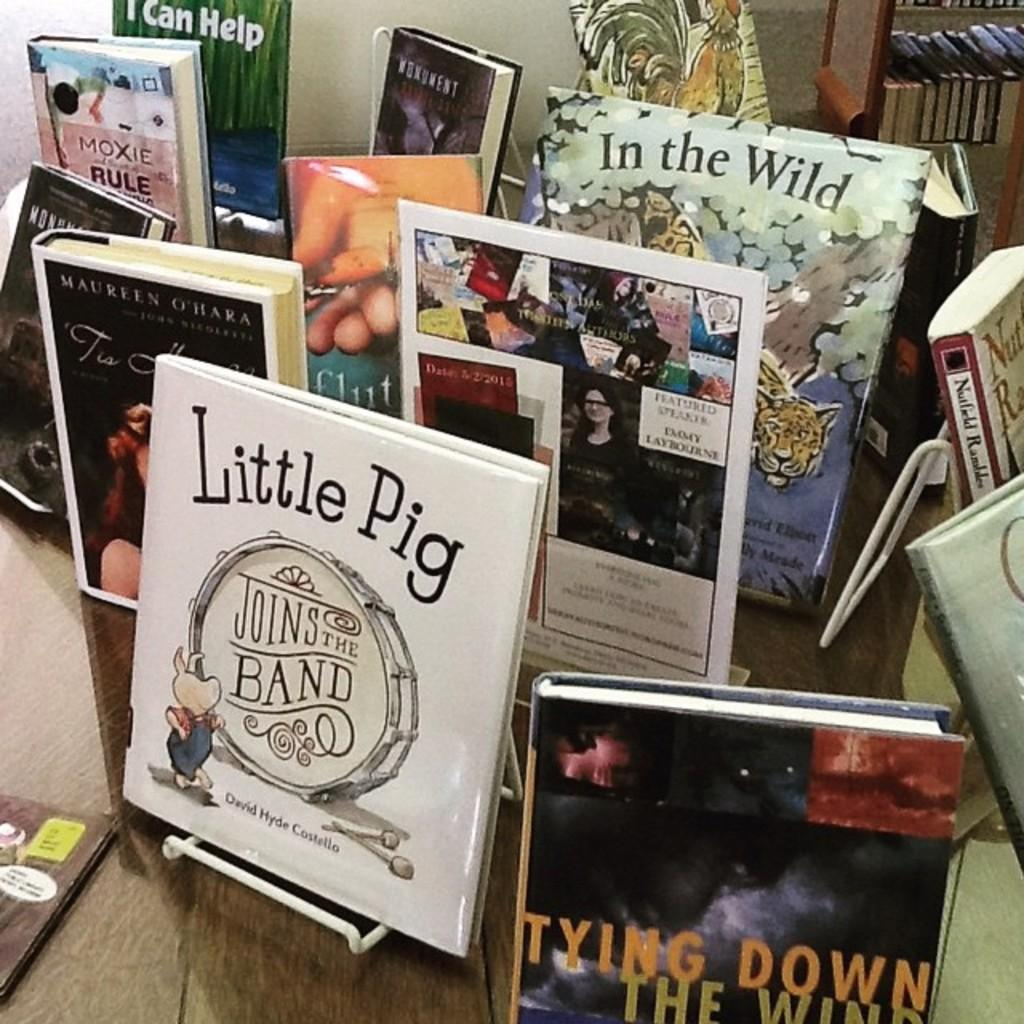<image>
Create a compact narrative representing the image presented. Several books on display including Little Pig Joins the Band and In the Wild 